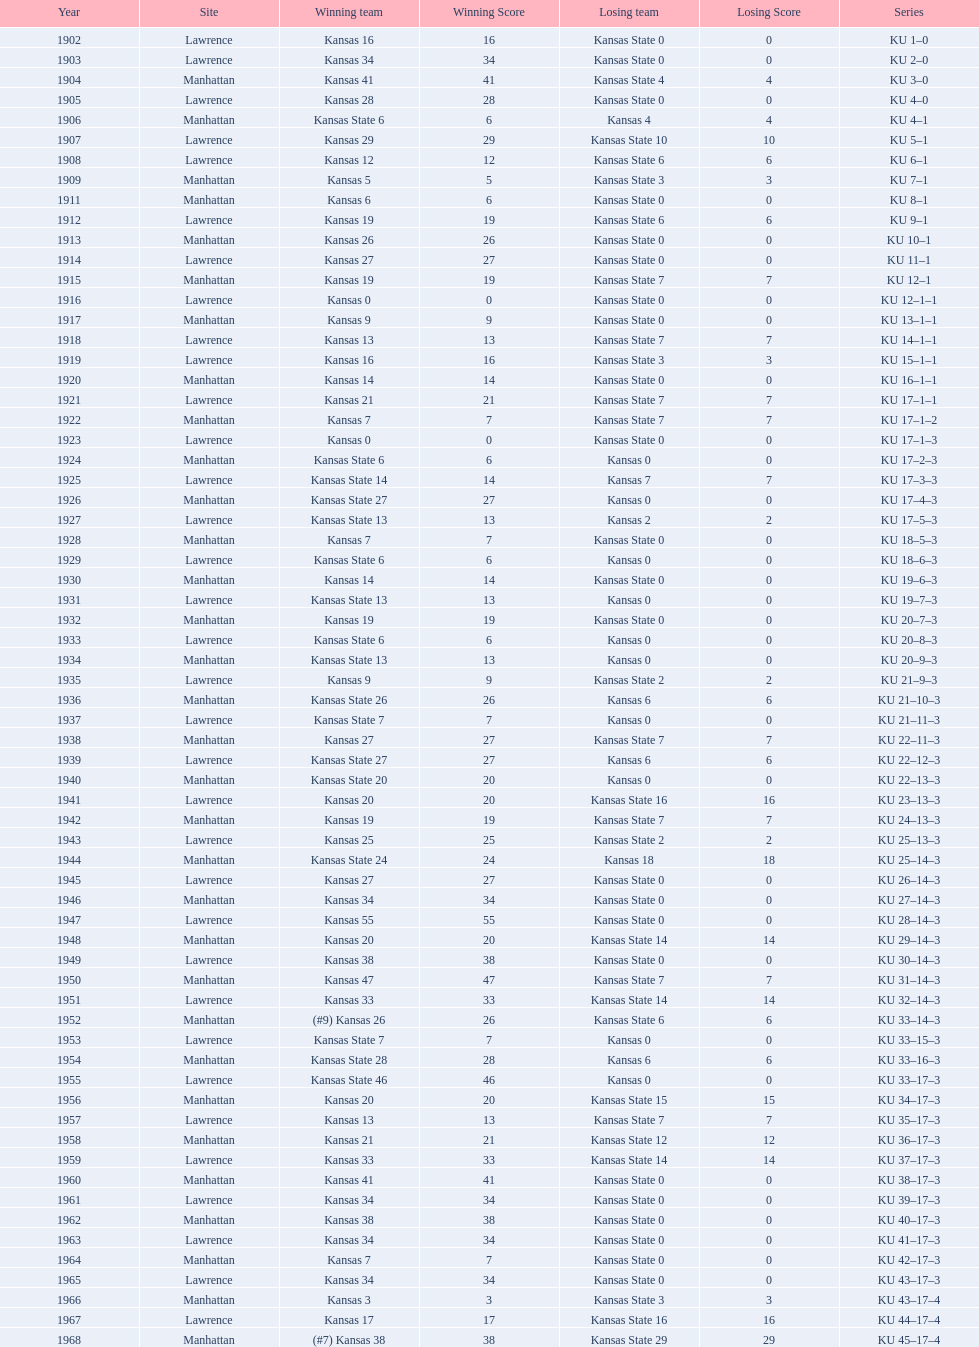When was the first game that kansas state won by double digits? 1926. 